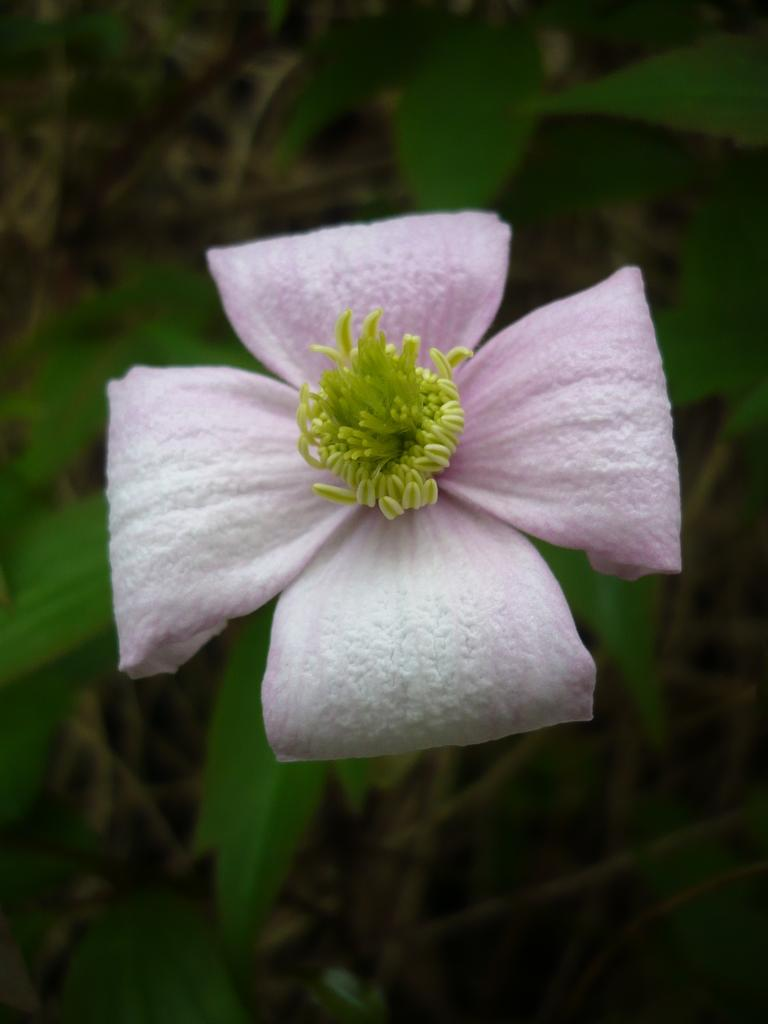What type of plant is depicted in the image? There is a flower in the image. What parts of the plant are visible in the image? There are leaves and a stem in the image. What type of hospital equipment can be seen in the image? There is no hospital equipment present in the image; it features a flower, leaves, and a stem. What type of glove is being worn by the flower in the image? There is no glove present in the image, as it features a flower, leaves, and a stem. 